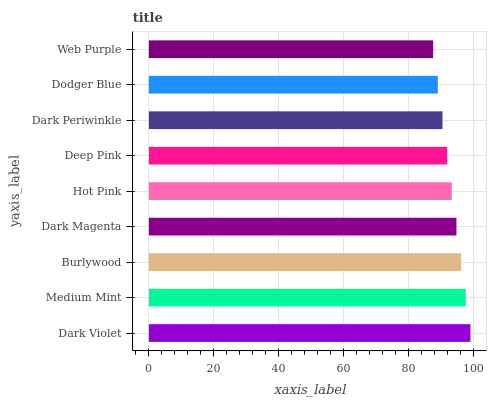Is Web Purple the minimum?
Answer yes or no. Yes. Is Dark Violet the maximum?
Answer yes or no. Yes. Is Medium Mint the minimum?
Answer yes or no. No. Is Medium Mint the maximum?
Answer yes or no. No. Is Dark Violet greater than Medium Mint?
Answer yes or no. Yes. Is Medium Mint less than Dark Violet?
Answer yes or no. Yes. Is Medium Mint greater than Dark Violet?
Answer yes or no. No. Is Dark Violet less than Medium Mint?
Answer yes or no. No. Is Hot Pink the high median?
Answer yes or no. Yes. Is Hot Pink the low median?
Answer yes or no. Yes. Is Dark Magenta the high median?
Answer yes or no. No. Is Web Purple the low median?
Answer yes or no. No. 